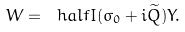Convert formula to latex. <formula><loc_0><loc_0><loc_500><loc_500>W = \ h a l f I ( \sigma _ { 0 } + i \widetilde { Q } ) Y .</formula> 